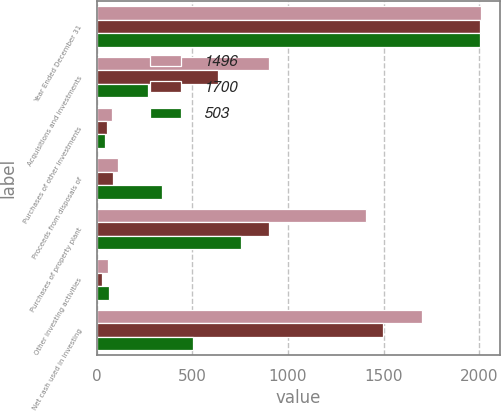Convert chart. <chart><loc_0><loc_0><loc_500><loc_500><stacked_bar_chart><ecel><fcel>Year Ended December 31<fcel>Acquisitions and investments<fcel>Purchases of other investments<fcel>Proceeds from disposals of<fcel>Purchases of property plant<fcel>Other investing activities<fcel>Net cash used in investing<nl><fcel>1496<fcel>2006<fcel>901<fcel>82<fcel>112<fcel>1407<fcel>62<fcel>1700<nl><fcel>1700<fcel>2005<fcel>637<fcel>53<fcel>88<fcel>899<fcel>28<fcel>1496<nl><fcel>503<fcel>2004<fcel>267<fcel>46<fcel>341<fcel>755<fcel>63<fcel>503<nl></chart> 